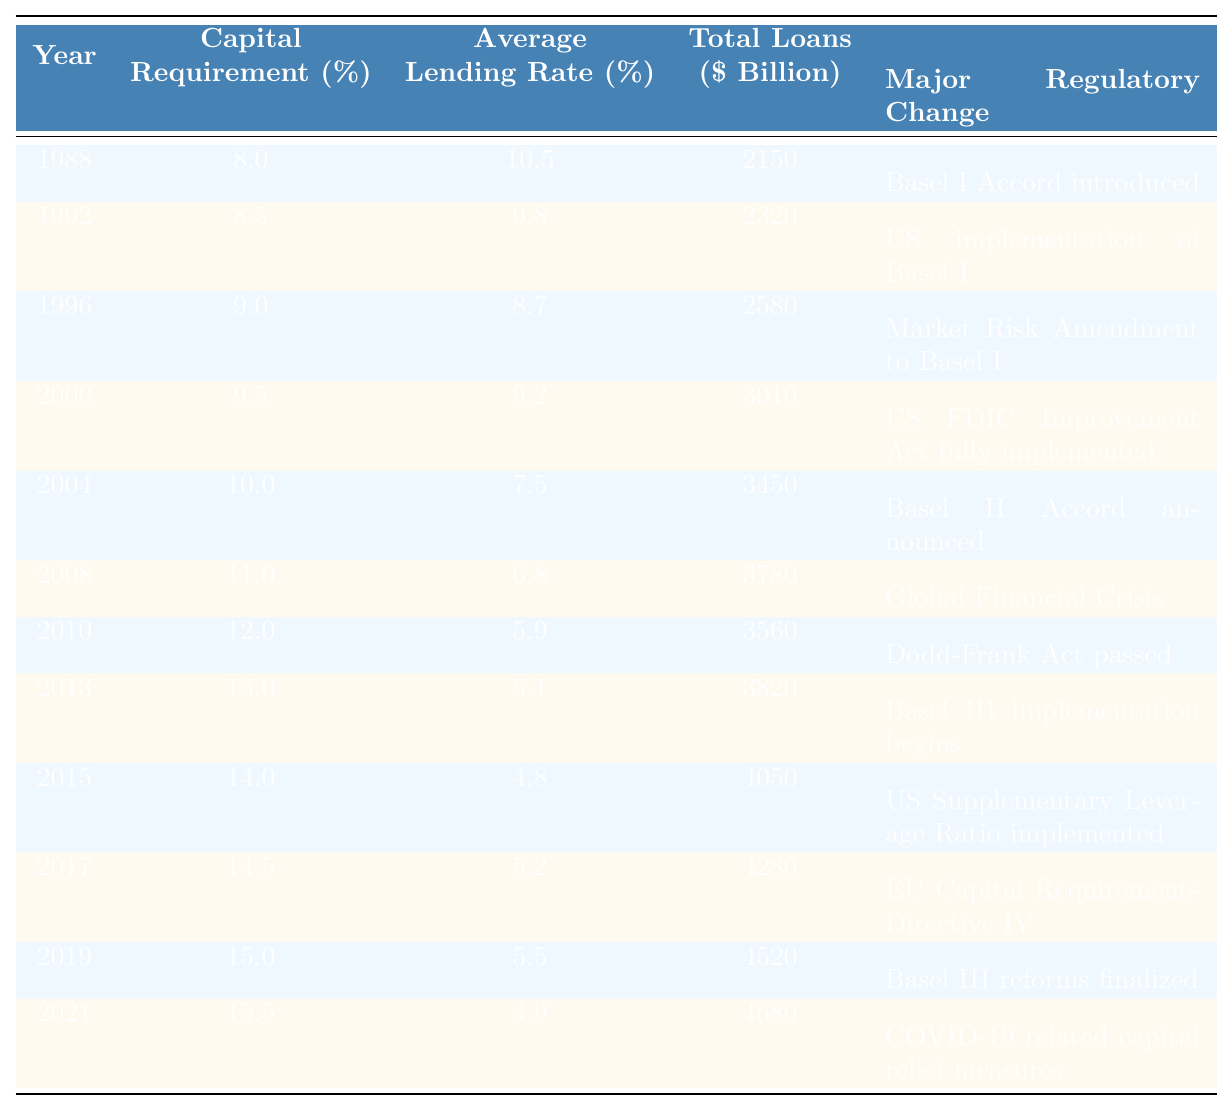What was the capital requirement in 2008? The table shows that in 2008, the capital requirement was 11.0%.
Answer: 11.0% What was the average lending rate in 2010? According to the table, the average lending rate in 2010 was 5.9%.
Answer: 5.9% Between which years did the total loans amount exceed $4000 billion? The table indicates that total loans exceeded $4000 billion from 2015 ($4050 billion) to 2021 ($4680 billion).
Answer: 2015 to 2021 What was the difference in average lending rates between 1996 and 2000? The average lending rate in 1996 was 8.7%, and in 2000 it was 9.2%; the difference is 9.2% - 8.7% = 0.5%.
Answer: 0.5% In which year did the capital requirement first exceed 14%? The capital requirement first exceeded 14% in 2015 when it reached 14.0%.
Answer: 2015 How did the average lending rate change from 2015 to 2019? The average lending rate decreased from 4.8% in 2015 to 5.5% in 2019, showing an increase of 0.7%.
Answer: Increased by 0.7% Is it true that the major regulatory changes led to a decrease in average lending rates over the years? Yes, the data show that as capital requirements rose, the average lending rates generally declined, especially post-2008.
Answer: Yes What is the trend of capital requirements from 1988 to 2021? From 1988 to 2021, capital requirements increased from 8.0% to 15.5%, showing a consistent upward trend.
Answer: Upward trend What were the average lending rates for the years when Basel regulatory accords were introduced? The average lending rates for the years with major Basel accords are: Basel I in 1988 (10.5%), Basel II in 2004 (7.5%), and Basel III in 2013 (5.1%). The average is (10.5 + 7.5 + 5.1) / 3 = 7.7%.
Answer: 7.7% What was the percentage increase in total loans from 2000 to 2008? The total loans increased from $3010 billion in 2000 to $3780 billion in 2008, which is an increase of ($3780 - $3010) / $3010 * 100 ≈ 25.5%.
Answer: 25.5% How many years did the average lending rate remain below 6%? The average lending rate was below 6% from 2010 to 2021, which is a total of 6 years.
Answer: 6 years 